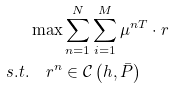Convert formula to latex. <formula><loc_0><loc_0><loc_500><loc_500>& \max \sum ^ { N } _ { n = 1 } \sum ^ { M } _ { i = 1 } \mu ^ { n T } \cdot r \\ s . t . & \quad r ^ { n } \in \mathcal { C } \left ( h , \bar { P } \right )</formula> 